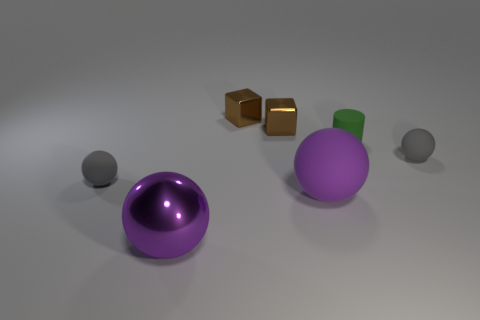What size is the other purple object that is the same shape as the purple shiny object?
Ensure brevity in your answer.  Large. Is there any other thing that is the same size as the green thing?
Give a very brief answer. Yes. Is the material of the small ball on the left side of the large rubber thing the same as the green object?
Your answer should be compact. Yes. The large matte thing that is the same shape as the big purple shiny thing is what color?
Your response must be concise. Purple. How many other objects are there of the same color as the big matte thing?
Offer a very short reply. 1. There is a big purple object that is behind the big purple metal ball; is its shape the same as the tiny gray thing on the right side of the large shiny ball?
Keep it short and to the point. Yes. What number of spheres are big metal things or tiny gray things?
Offer a very short reply. 3. Are there fewer big balls that are in front of the purple metallic sphere than purple metal objects?
Your answer should be very brief. Yes. How many other things are the same material as the cylinder?
Make the answer very short. 3. Do the green cylinder and the metal sphere have the same size?
Keep it short and to the point. No. 